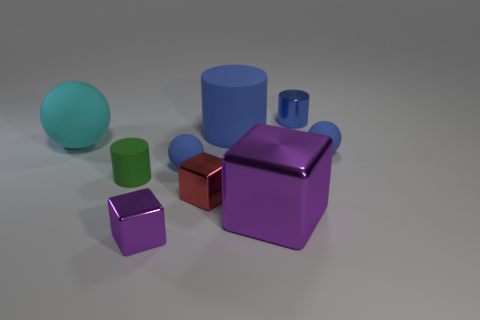Add 1 rubber things. How many objects exist? 10 Subtract all spheres. How many objects are left? 6 Add 1 purple objects. How many purple objects are left? 3 Add 2 big metallic things. How many big metallic things exist? 3 Subtract 2 blue cylinders. How many objects are left? 7 Subtract all cyan objects. Subtract all tiny red shiny objects. How many objects are left? 7 